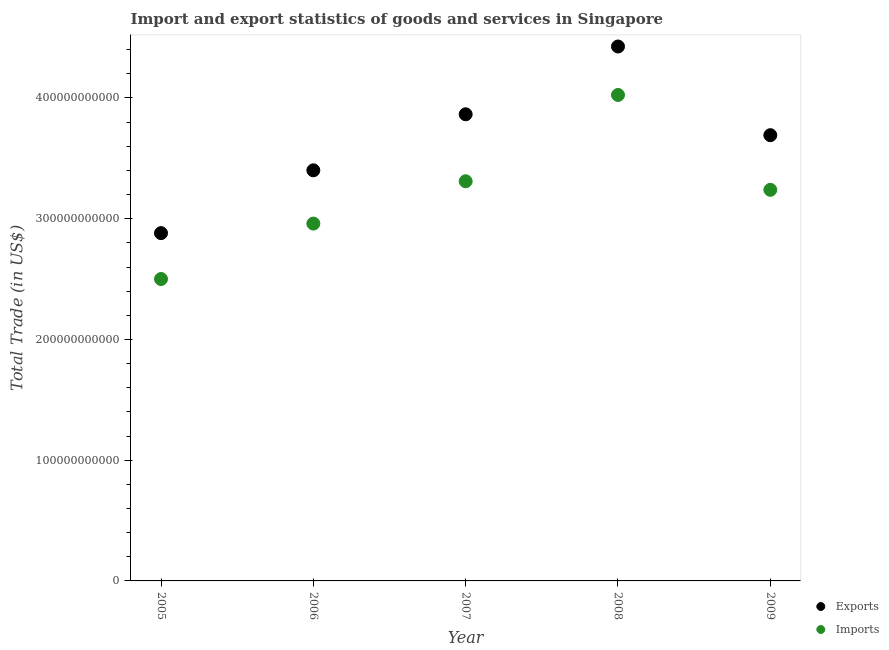What is the imports of goods and services in 2006?
Make the answer very short. 2.96e+11. Across all years, what is the maximum imports of goods and services?
Offer a terse response. 4.02e+11. Across all years, what is the minimum imports of goods and services?
Your answer should be compact. 2.50e+11. What is the total export of goods and services in the graph?
Keep it short and to the point. 1.83e+12. What is the difference between the imports of goods and services in 2006 and that in 2008?
Give a very brief answer. -1.07e+11. What is the difference between the export of goods and services in 2007 and the imports of goods and services in 2006?
Provide a succinct answer. 9.05e+1. What is the average imports of goods and services per year?
Your answer should be very brief. 3.21e+11. In the year 2005, what is the difference between the export of goods and services and imports of goods and services?
Offer a very short reply. 3.80e+1. In how many years, is the export of goods and services greater than 120000000000 US$?
Your answer should be very brief. 5. What is the ratio of the imports of goods and services in 2005 to that in 2006?
Your answer should be compact. 0.84. Is the imports of goods and services in 2005 less than that in 2007?
Keep it short and to the point. Yes. What is the difference between the highest and the second highest export of goods and services?
Your response must be concise. 5.61e+1. What is the difference between the highest and the lowest export of goods and services?
Your answer should be compact. 1.55e+11. In how many years, is the export of goods and services greater than the average export of goods and services taken over all years?
Make the answer very short. 3. Does the export of goods and services monotonically increase over the years?
Offer a terse response. No. Is the imports of goods and services strictly greater than the export of goods and services over the years?
Ensure brevity in your answer.  No. Is the export of goods and services strictly less than the imports of goods and services over the years?
Keep it short and to the point. No. How many dotlines are there?
Keep it short and to the point. 2. How many years are there in the graph?
Your response must be concise. 5. What is the difference between two consecutive major ticks on the Y-axis?
Ensure brevity in your answer.  1.00e+11. Are the values on the major ticks of Y-axis written in scientific E-notation?
Offer a very short reply. No. Does the graph contain any zero values?
Keep it short and to the point. No. Does the graph contain grids?
Your answer should be very brief. No. Where does the legend appear in the graph?
Provide a short and direct response. Bottom right. How many legend labels are there?
Make the answer very short. 2. How are the legend labels stacked?
Offer a terse response. Vertical. What is the title of the graph?
Provide a succinct answer. Import and export statistics of goods and services in Singapore. What is the label or title of the Y-axis?
Provide a succinct answer. Total Trade (in US$). What is the Total Trade (in US$) in Exports in 2005?
Ensure brevity in your answer.  2.88e+11. What is the Total Trade (in US$) of Imports in 2005?
Offer a very short reply. 2.50e+11. What is the Total Trade (in US$) in Exports in 2006?
Offer a terse response. 3.40e+11. What is the Total Trade (in US$) of Imports in 2006?
Ensure brevity in your answer.  2.96e+11. What is the Total Trade (in US$) in Exports in 2007?
Ensure brevity in your answer.  3.86e+11. What is the Total Trade (in US$) in Imports in 2007?
Give a very brief answer. 3.31e+11. What is the Total Trade (in US$) in Exports in 2008?
Make the answer very short. 4.43e+11. What is the Total Trade (in US$) in Imports in 2008?
Provide a short and direct response. 4.02e+11. What is the Total Trade (in US$) of Exports in 2009?
Offer a very short reply. 3.69e+11. What is the Total Trade (in US$) of Imports in 2009?
Make the answer very short. 3.24e+11. Across all years, what is the maximum Total Trade (in US$) in Exports?
Keep it short and to the point. 4.43e+11. Across all years, what is the maximum Total Trade (in US$) of Imports?
Give a very brief answer. 4.02e+11. Across all years, what is the minimum Total Trade (in US$) of Exports?
Your response must be concise. 2.88e+11. Across all years, what is the minimum Total Trade (in US$) in Imports?
Your answer should be compact. 2.50e+11. What is the total Total Trade (in US$) of Exports in the graph?
Offer a very short reply. 1.83e+12. What is the total Total Trade (in US$) of Imports in the graph?
Your answer should be compact. 1.60e+12. What is the difference between the Total Trade (in US$) in Exports in 2005 and that in 2006?
Your answer should be compact. -5.20e+1. What is the difference between the Total Trade (in US$) of Imports in 2005 and that in 2006?
Your answer should be compact. -4.59e+1. What is the difference between the Total Trade (in US$) of Exports in 2005 and that in 2007?
Your answer should be compact. -9.84e+1. What is the difference between the Total Trade (in US$) of Imports in 2005 and that in 2007?
Give a very brief answer. -8.10e+1. What is the difference between the Total Trade (in US$) in Exports in 2005 and that in 2008?
Provide a short and direct response. -1.55e+11. What is the difference between the Total Trade (in US$) of Imports in 2005 and that in 2008?
Offer a terse response. -1.52e+11. What is the difference between the Total Trade (in US$) of Exports in 2005 and that in 2009?
Offer a terse response. -8.11e+1. What is the difference between the Total Trade (in US$) of Imports in 2005 and that in 2009?
Offer a terse response. -7.39e+1. What is the difference between the Total Trade (in US$) of Exports in 2006 and that in 2007?
Offer a terse response. -4.64e+1. What is the difference between the Total Trade (in US$) of Imports in 2006 and that in 2007?
Make the answer very short. -3.50e+1. What is the difference between the Total Trade (in US$) of Exports in 2006 and that in 2008?
Ensure brevity in your answer.  -1.03e+11. What is the difference between the Total Trade (in US$) in Imports in 2006 and that in 2008?
Your answer should be compact. -1.07e+11. What is the difference between the Total Trade (in US$) of Exports in 2006 and that in 2009?
Give a very brief answer. -2.91e+1. What is the difference between the Total Trade (in US$) of Imports in 2006 and that in 2009?
Provide a succinct answer. -2.80e+1. What is the difference between the Total Trade (in US$) of Exports in 2007 and that in 2008?
Give a very brief answer. -5.61e+1. What is the difference between the Total Trade (in US$) in Imports in 2007 and that in 2008?
Keep it short and to the point. -7.15e+1. What is the difference between the Total Trade (in US$) of Exports in 2007 and that in 2009?
Give a very brief answer. 1.73e+1. What is the difference between the Total Trade (in US$) of Imports in 2007 and that in 2009?
Keep it short and to the point. 7.09e+09. What is the difference between the Total Trade (in US$) of Exports in 2008 and that in 2009?
Provide a succinct answer. 7.34e+1. What is the difference between the Total Trade (in US$) of Imports in 2008 and that in 2009?
Make the answer very short. 7.86e+1. What is the difference between the Total Trade (in US$) of Exports in 2005 and the Total Trade (in US$) of Imports in 2006?
Your answer should be very brief. -7.90e+09. What is the difference between the Total Trade (in US$) of Exports in 2005 and the Total Trade (in US$) of Imports in 2007?
Offer a terse response. -4.29e+1. What is the difference between the Total Trade (in US$) of Exports in 2005 and the Total Trade (in US$) of Imports in 2008?
Make the answer very short. -1.14e+11. What is the difference between the Total Trade (in US$) of Exports in 2005 and the Total Trade (in US$) of Imports in 2009?
Give a very brief answer. -3.59e+1. What is the difference between the Total Trade (in US$) in Exports in 2006 and the Total Trade (in US$) in Imports in 2007?
Your answer should be compact. 9.07e+09. What is the difference between the Total Trade (in US$) in Exports in 2006 and the Total Trade (in US$) in Imports in 2008?
Your answer should be compact. -6.24e+1. What is the difference between the Total Trade (in US$) in Exports in 2006 and the Total Trade (in US$) in Imports in 2009?
Your answer should be compact. 1.62e+1. What is the difference between the Total Trade (in US$) in Exports in 2007 and the Total Trade (in US$) in Imports in 2008?
Offer a very short reply. -1.60e+1. What is the difference between the Total Trade (in US$) in Exports in 2007 and the Total Trade (in US$) in Imports in 2009?
Make the answer very short. 6.26e+1. What is the difference between the Total Trade (in US$) in Exports in 2008 and the Total Trade (in US$) in Imports in 2009?
Your answer should be compact. 1.19e+11. What is the average Total Trade (in US$) in Exports per year?
Offer a terse response. 3.65e+11. What is the average Total Trade (in US$) of Imports per year?
Give a very brief answer. 3.21e+11. In the year 2005, what is the difference between the Total Trade (in US$) of Exports and Total Trade (in US$) of Imports?
Your response must be concise. 3.80e+1. In the year 2006, what is the difference between the Total Trade (in US$) of Exports and Total Trade (in US$) of Imports?
Provide a short and direct response. 4.41e+1. In the year 2007, what is the difference between the Total Trade (in US$) of Exports and Total Trade (in US$) of Imports?
Your answer should be very brief. 5.55e+1. In the year 2008, what is the difference between the Total Trade (in US$) in Exports and Total Trade (in US$) in Imports?
Provide a succinct answer. 4.01e+1. In the year 2009, what is the difference between the Total Trade (in US$) in Exports and Total Trade (in US$) in Imports?
Your response must be concise. 4.53e+1. What is the ratio of the Total Trade (in US$) of Exports in 2005 to that in 2006?
Give a very brief answer. 0.85. What is the ratio of the Total Trade (in US$) of Imports in 2005 to that in 2006?
Offer a very short reply. 0.84. What is the ratio of the Total Trade (in US$) of Exports in 2005 to that in 2007?
Ensure brevity in your answer.  0.75. What is the ratio of the Total Trade (in US$) of Imports in 2005 to that in 2007?
Provide a short and direct response. 0.76. What is the ratio of the Total Trade (in US$) of Exports in 2005 to that in 2008?
Your answer should be compact. 0.65. What is the ratio of the Total Trade (in US$) of Imports in 2005 to that in 2008?
Your response must be concise. 0.62. What is the ratio of the Total Trade (in US$) in Exports in 2005 to that in 2009?
Give a very brief answer. 0.78. What is the ratio of the Total Trade (in US$) in Imports in 2005 to that in 2009?
Keep it short and to the point. 0.77. What is the ratio of the Total Trade (in US$) of Exports in 2006 to that in 2007?
Your answer should be compact. 0.88. What is the ratio of the Total Trade (in US$) of Imports in 2006 to that in 2007?
Offer a very short reply. 0.89. What is the ratio of the Total Trade (in US$) in Exports in 2006 to that in 2008?
Your answer should be compact. 0.77. What is the ratio of the Total Trade (in US$) of Imports in 2006 to that in 2008?
Your answer should be compact. 0.74. What is the ratio of the Total Trade (in US$) of Exports in 2006 to that in 2009?
Provide a short and direct response. 0.92. What is the ratio of the Total Trade (in US$) in Imports in 2006 to that in 2009?
Offer a very short reply. 0.91. What is the ratio of the Total Trade (in US$) of Exports in 2007 to that in 2008?
Your answer should be very brief. 0.87. What is the ratio of the Total Trade (in US$) in Imports in 2007 to that in 2008?
Provide a succinct answer. 0.82. What is the ratio of the Total Trade (in US$) in Exports in 2007 to that in 2009?
Offer a terse response. 1.05. What is the ratio of the Total Trade (in US$) of Imports in 2007 to that in 2009?
Your response must be concise. 1.02. What is the ratio of the Total Trade (in US$) in Exports in 2008 to that in 2009?
Offer a terse response. 1.2. What is the ratio of the Total Trade (in US$) in Imports in 2008 to that in 2009?
Provide a short and direct response. 1.24. What is the difference between the highest and the second highest Total Trade (in US$) of Exports?
Your answer should be compact. 5.61e+1. What is the difference between the highest and the second highest Total Trade (in US$) in Imports?
Your response must be concise. 7.15e+1. What is the difference between the highest and the lowest Total Trade (in US$) in Exports?
Offer a terse response. 1.55e+11. What is the difference between the highest and the lowest Total Trade (in US$) of Imports?
Your answer should be compact. 1.52e+11. 